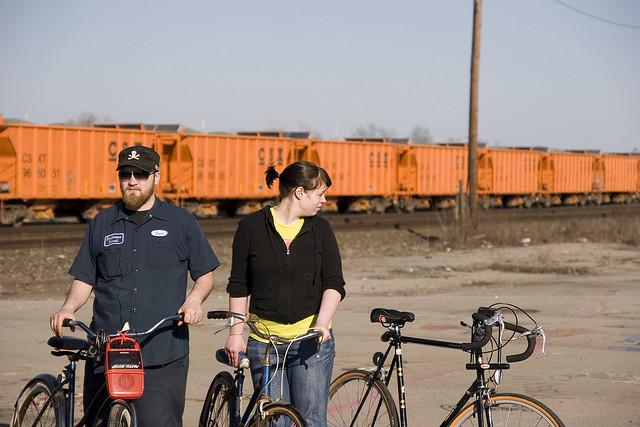How many bicycles are pictured?
Concise answer only. 3. Are there riders on these bicycles?
Keep it brief. No. Is this near water?
Concise answer only. No. Where is the woman looking?
Concise answer only. Left. Is there a passenger train in this picture?
Keep it brief. No. What is the woman carrying?
Concise answer only. Bike. How many bikes are there?
Keep it brief. 3. What are the men riding?
Short answer required. Bicycles. Where are the bicyclists?
Write a very short answer. Train tracks. 